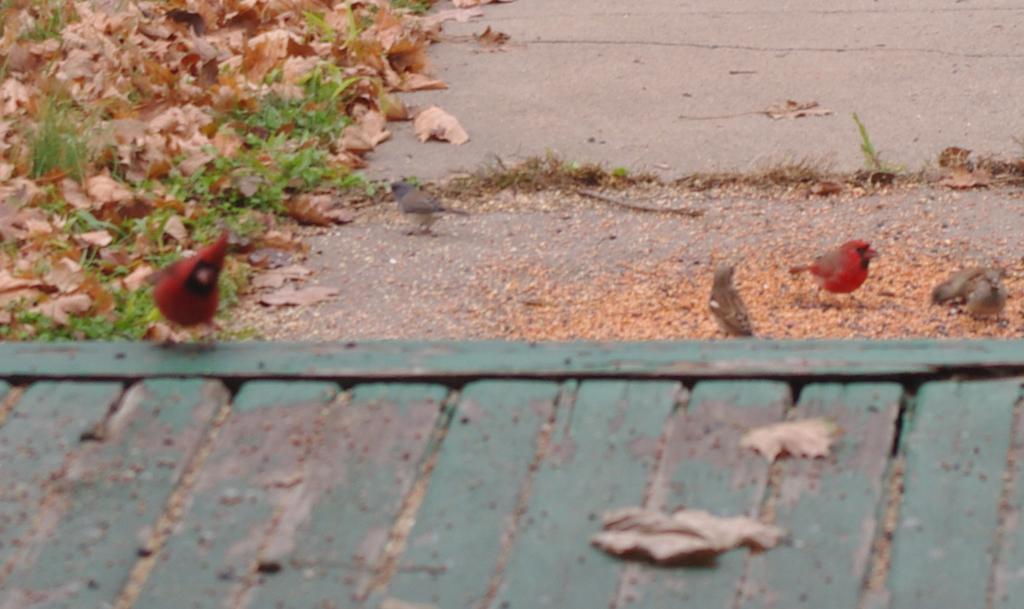Could you give a brief overview of what you see in this image? This image consists of birds. At the bottom, it looks like a roof. And we can see the dried leaves on the road. 